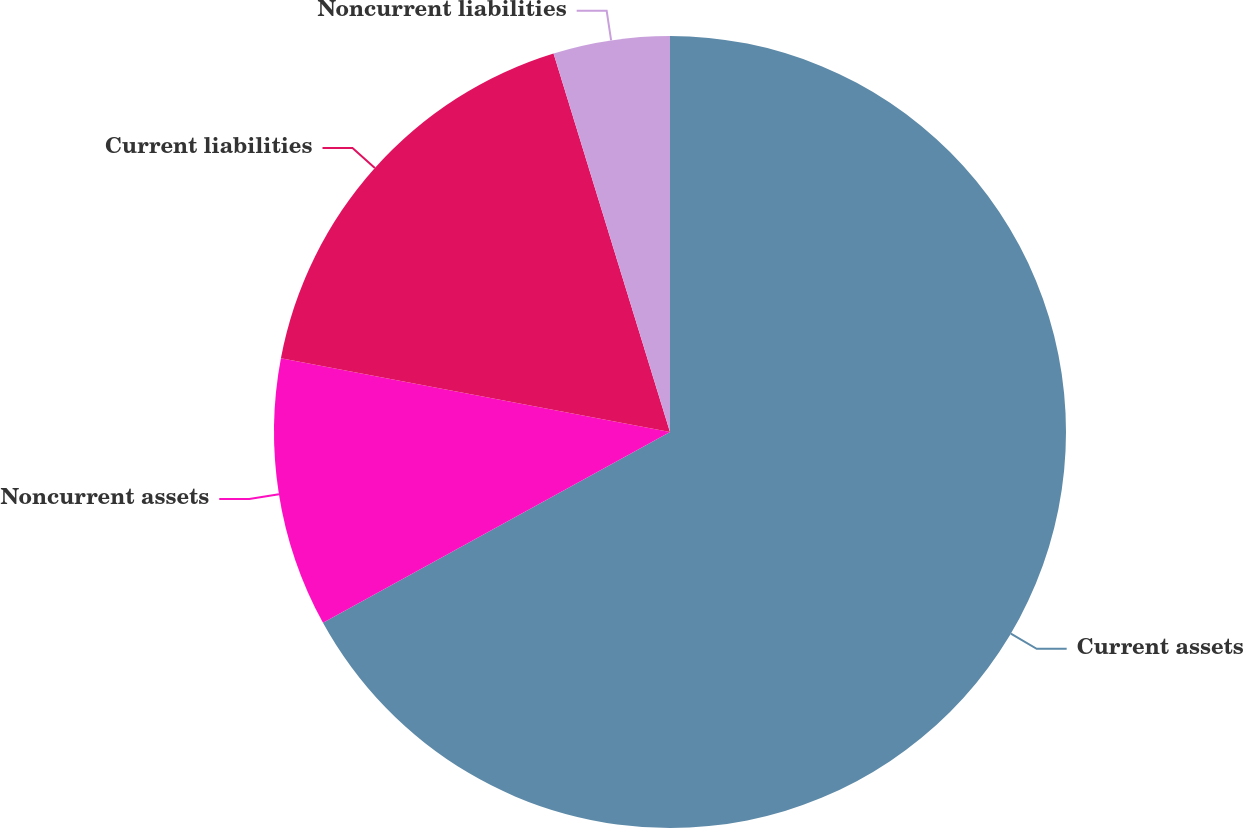Convert chart to OTSL. <chart><loc_0><loc_0><loc_500><loc_500><pie_chart><fcel>Current assets<fcel>Noncurrent assets<fcel>Current liabilities<fcel>Noncurrent liabilities<nl><fcel>67.0%<fcel>10.98%<fcel>17.27%<fcel>4.75%<nl></chart> 